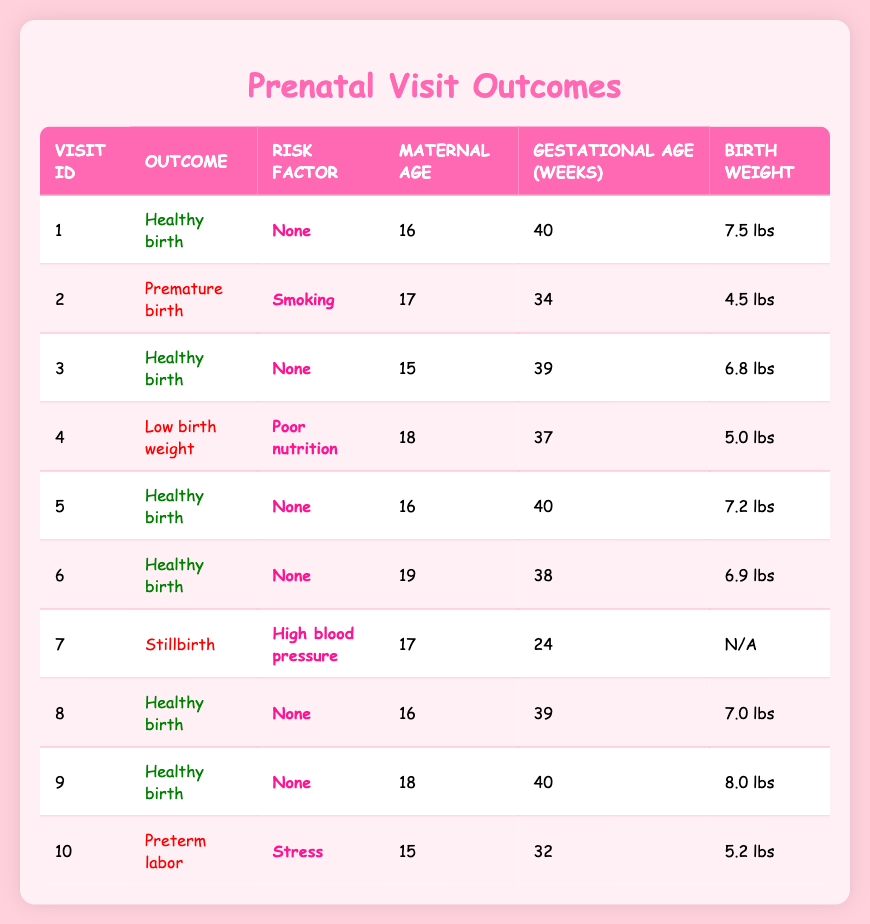What is the outcome of visit ID 3? From the table, we can see that visit ID 3 has the outcome listed as "Healthy birth."
Answer: Healthy birth How many visits resulted in a healthy birth? We count the rows that contain "Healthy birth" in the outcome column. There are six visits (ID 1, 3, 5, 6, 8, 9) with this outcome.
Answer: 6 What is the birth weight for the visit with ID 2? Looking at the table, visit ID 2 has a birth weight listed as "4.5 lbs."
Answer: 4.5 lbs Is there any visit with a risk factor of "None" that resulted in stillbirth? By examining the table, we can check all visits with the risk factor "None" which resulted in healthy births. There are no records indicating stillbirths with this risk factor, confirming the statement is false.
Answer: No What is the average gestational age in weeks for visits that resulted in low birth weight or preterm labor? First, we identify the relevant visits: ID 4 (low birth weight) and ID 10 (preterm labor). Their gestational ages are 37 and 32 weeks respectively. We calculate the average: (37 + 32) / 2 = 34.5 weeks.
Answer: 34.5 weeks How many of the visits involved maternal age of 17 years? From the data, visit IDs 2 and 7 list maternal ages of 17 years, so we count these entries. There are two such visits.
Answer: 2 What is the maximum birth weight recorded in the visits? By checking the birth weight column, the highest value is 8.0 lbs from visit ID 9, thus it is our maximum birth weight.
Answer: 8.0 lbs Do any visits indicate a risk factor of "High blood pressure"? Checking the risk factor column, we see that visit ID 7 has the risk factor "High blood pressure," which confirms the presence of this risk.
Answer: Yes Which visit has the lowest gestational age and what is it? Reviewing the gestational age column, visit ID 7 has the lowest at 24 weeks, making it the answer to our question.
Answer: 24 weeks 